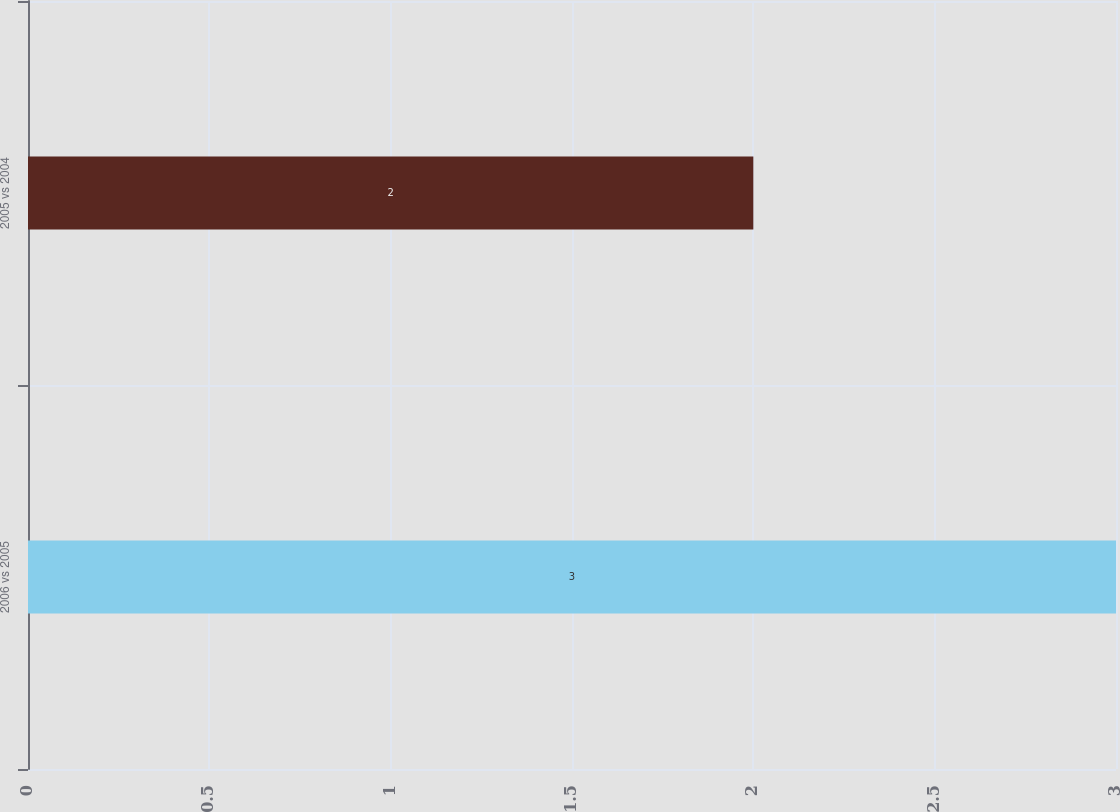<chart> <loc_0><loc_0><loc_500><loc_500><bar_chart><fcel>2006 vs 2005<fcel>2005 vs 2004<nl><fcel>3<fcel>2<nl></chart> 